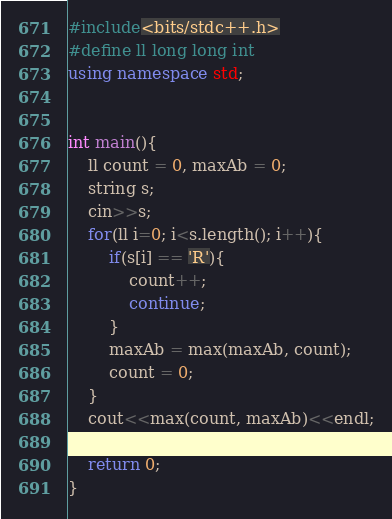Convert code to text. <code><loc_0><loc_0><loc_500><loc_500><_C++_>#include<bits/stdc++.h>
#define ll long long int
using namespace std;


int main(){
	ll count = 0, maxAb = 0;
	string s;
	cin>>s;
	for(ll i=0; i<s.length(); i++){
		if(s[i] == 'R'){
			count++;
			continue;
		}
		maxAb = max(maxAb, count);
		count = 0;
	}
	cout<<max(count, maxAb)<<endl;

	return 0;
}</code> 